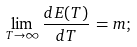Convert formula to latex. <formula><loc_0><loc_0><loc_500><loc_500>\lim _ { T \rightarrow \infty } \frac { d E ( T ) } { d T } \, = m ;</formula> 